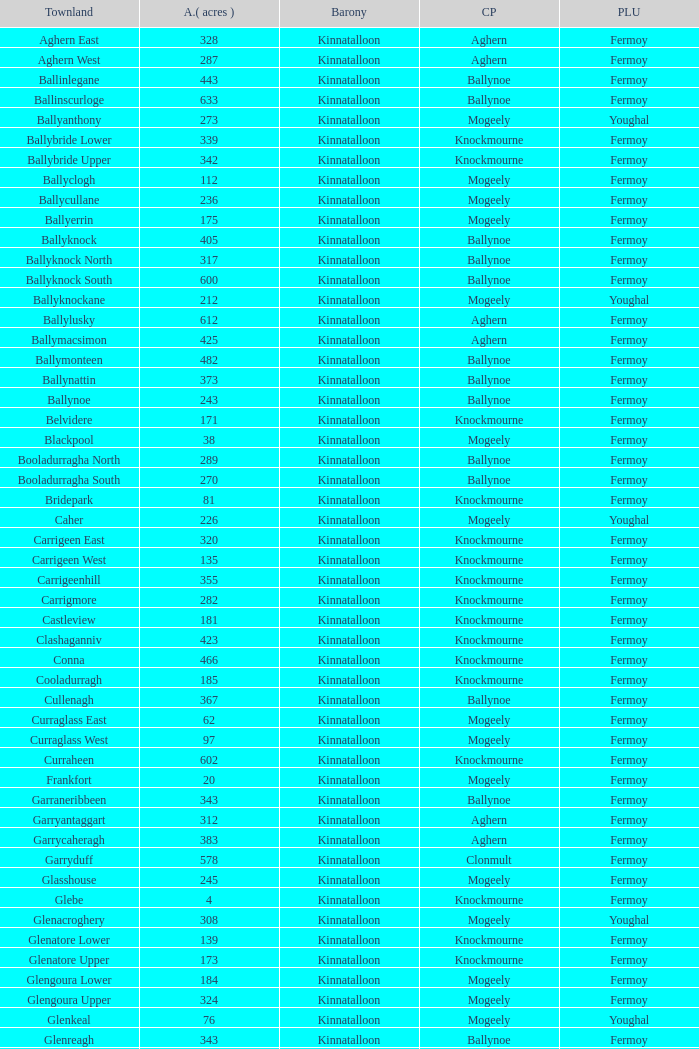Name the area for civil parish ballynoe and killasseragh 340.0. 